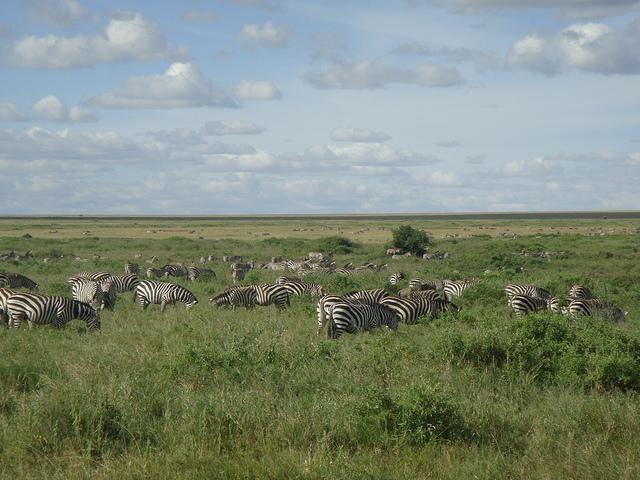How many zebras can be seen?
Give a very brief answer. 3. 